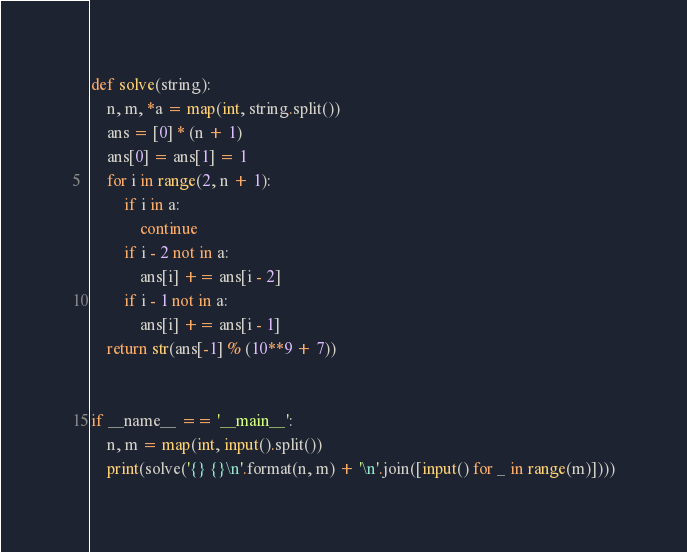<code> <loc_0><loc_0><loc_500><loc_500><_Python_>def solve(string):
    n, m, *a = map(int, string.split())
    ans = [0] * (n + 1)
    ans[0] = ans[1] = 1
    for i in range(2, n + 1):
        if i in a:
            continue
        if i - 2 not in a:
            ans[i] += ans[i - 2]
        if i - 1 not in a:
            ans[i] += ans[i - 1]
    return str(ans[-1] % (10**9 + 7))


if __name__ == '__main__':
    n, m = map(int, input().split())
    print(solve('{} {}\n'.format(n, m) + '\n'.join([input() for _ in range(m)])))
</code> 